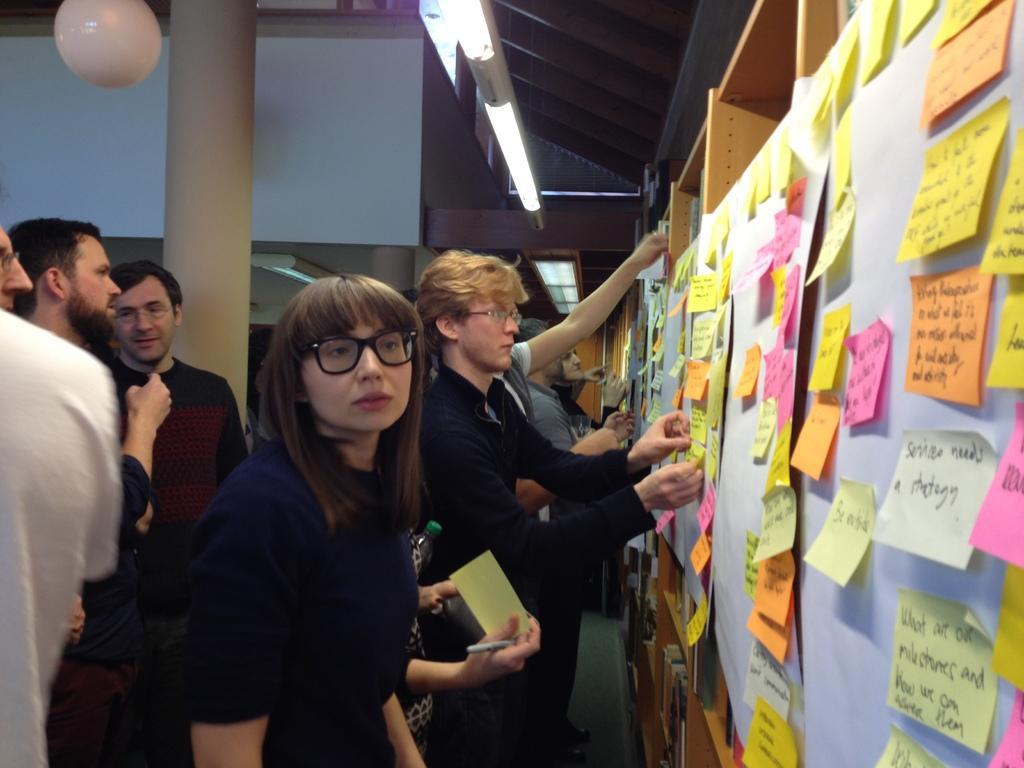Describe this image in one or two sentences. This image consists of many persons. To the right, there is a board on which the persons are pasting the papers. In the background, there is a wall along with a pillar. 